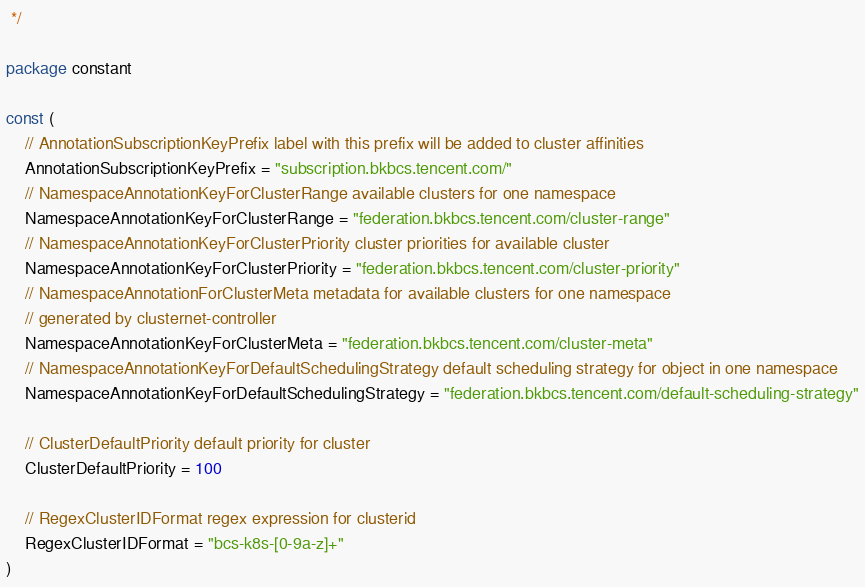Convert code to text. <code><loc_0><loc_0><loc_500><loc_500><_Go_> */

package constant

const (
	// AnnotationSubscriptionKeyPrefix label with this prefix will be added to cluster affinities
	AnnotationSubscriptionKeyPrefix = "subscription.bkbcs.tencent.com/"
	// NamespaceAnnotationKeyForClusterRange available clusters for one namespace
	NamespaceAnnotationKeyForClusterRange = "federation.bkbcs.tencent.com/cluster-range"
	// NamespaceAnnotationKeyForClusterPriority cluster priorities for available cluster
	NamespaceAnnotationKeyForClusterPriority = "federation.bkbcs.tencent.com/cluster-priority"
	// NamespaceAnnotationForClusterMeta metadata for available clusters for one namespace
	// generated by clusternet-controller
	NamespaceAnnotationKeyForClusterMeta = "federation.bkbcs.tencent.com/cluster-meta"
	// NamespaceAnnotationKeyForDefaultSchedulingStrategy default scheduling strategy for object in one namespace
	NamespaceAnnotationKeyForDefaultSchedulingStrategy = "federation.bkbcs.tencent.com/default-scheduling-strategy"

	// ClusterDefaultPriority default priority for cluster
	ClusterDefaultPriority = 100

	// RegexClusterIDFormat regex expression for clusterid
	RegexClusterIDFormat = "bcs-k8s-[0-9a-z]+"
)
</code> 